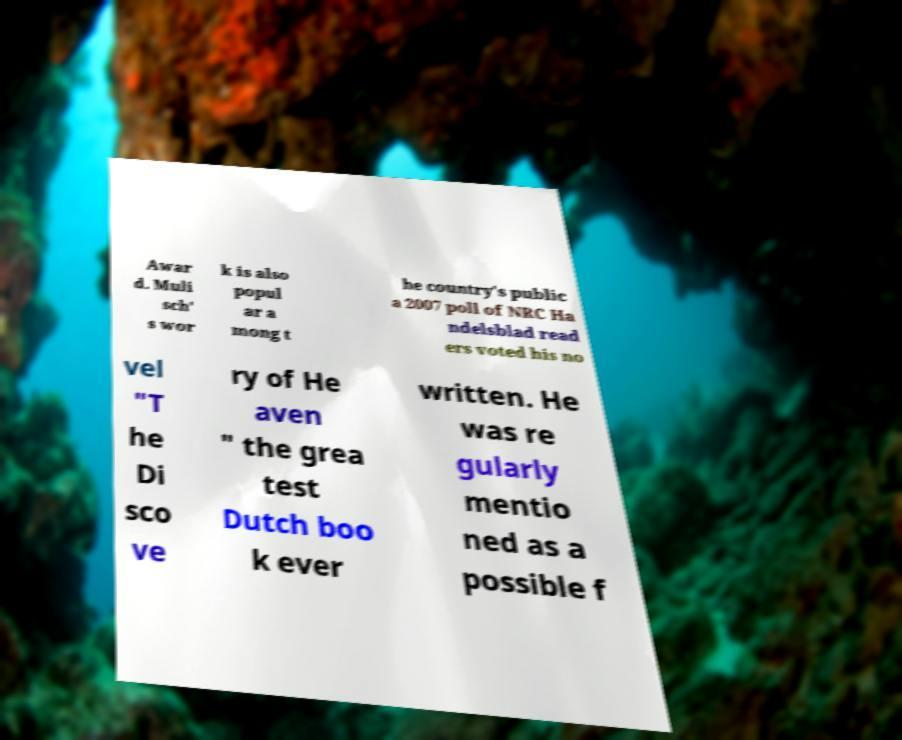Please identify and transcribe the text found in this image. Awar d. Muli sch' s wor k is also popul ar a mong t he country's public a 2007 poll of NRC Ha ndelsblad read ers voted his no vel "T he Di sco ve ry of He aven " the grea test Dutch boo k ever written. He was re gularly mentio ned as a possible f 